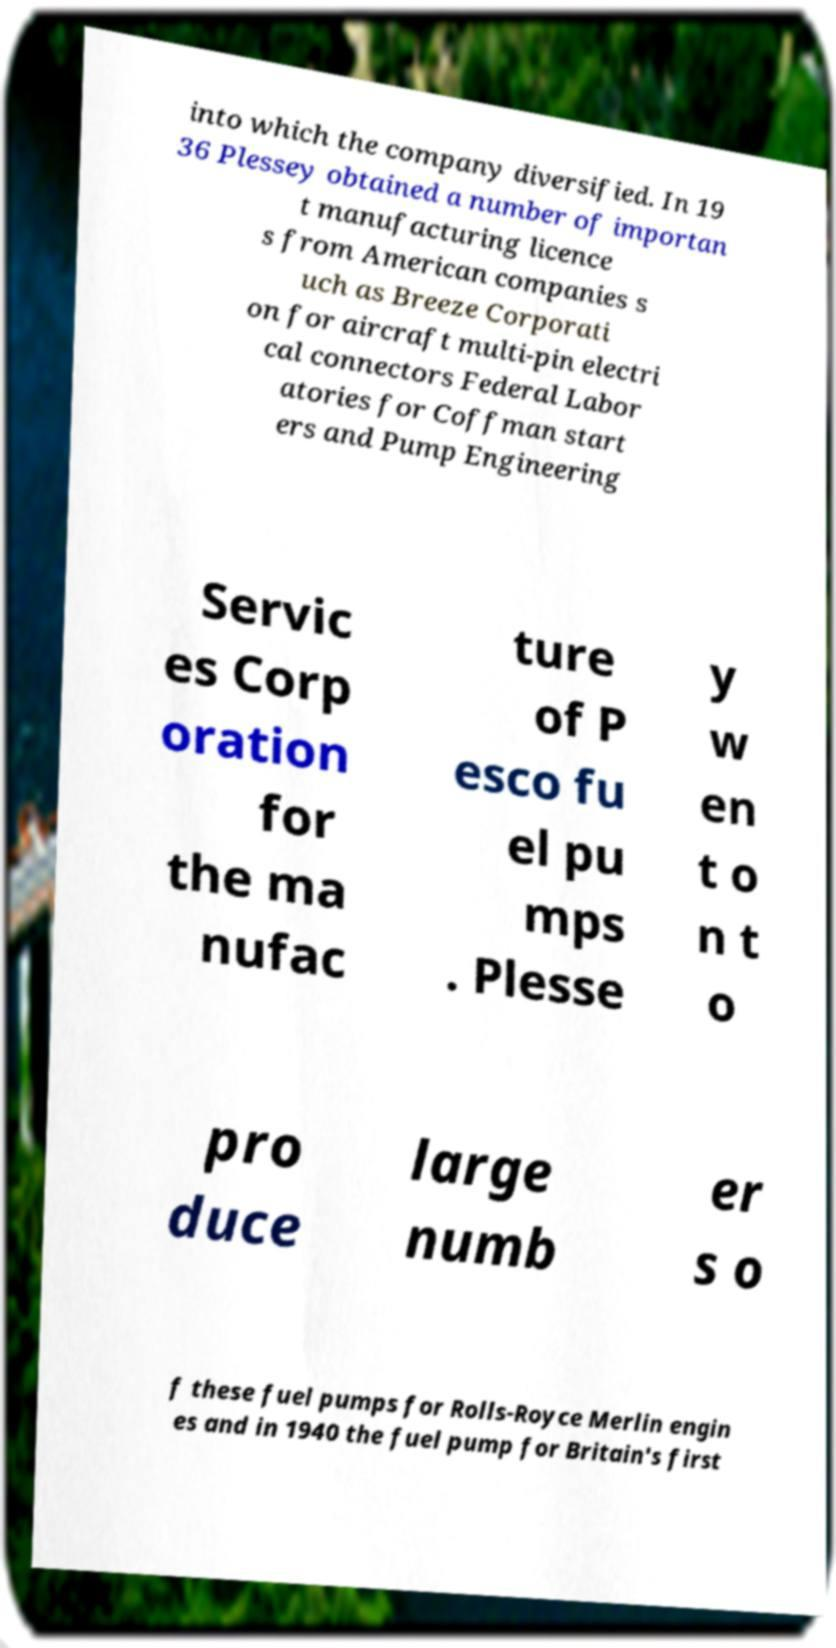For documentation purposes, I need the text within this image transcribed. Could you provide that? into which the company diversified. In 19 36 Plessey obtained a number of importan t manufacturing licence s from American companies s uch as Breeze Corporati on for aircraft multi-pin electri cal connectors Federal Labor atories for Coffman start ers and Pump Engineering Servic es Corp oration for the ma nufac ture of P esco fu el pu mps . Plesse y w en t o n t o pro duce large numb er s o f these fuel pumps for Rolls-Royce Merlin engin es and in 1940 the fuel pump for Britain's first 